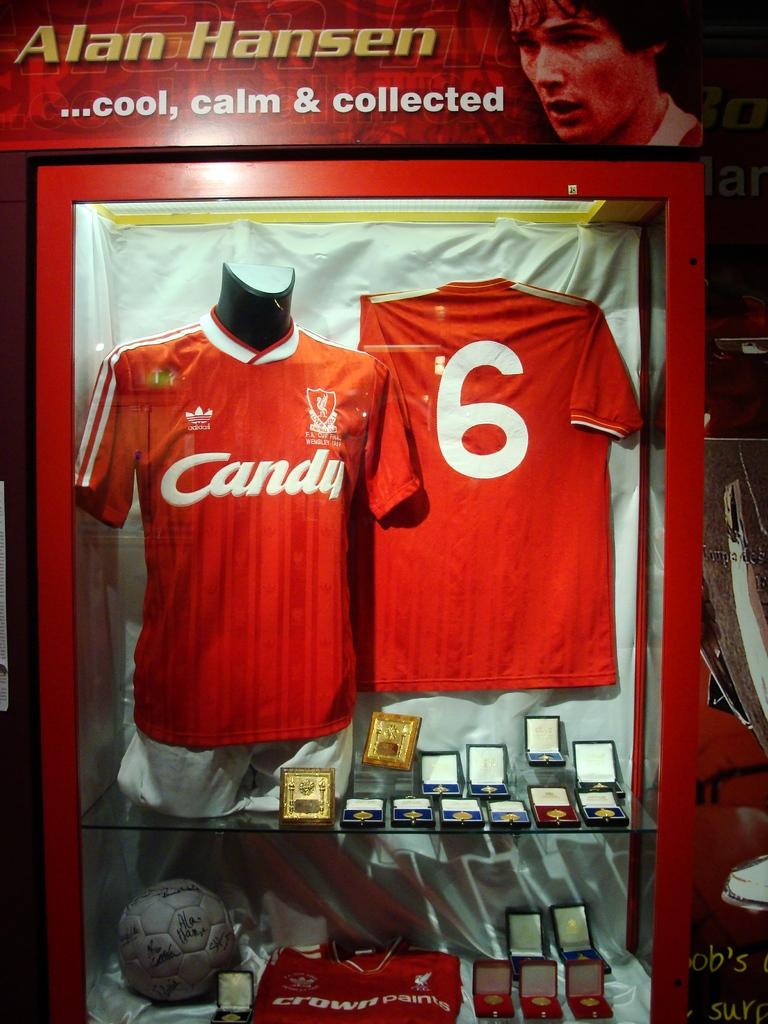Provide a one-sentence caption for the provided image. 2 red jerseys that read candy number 6. 